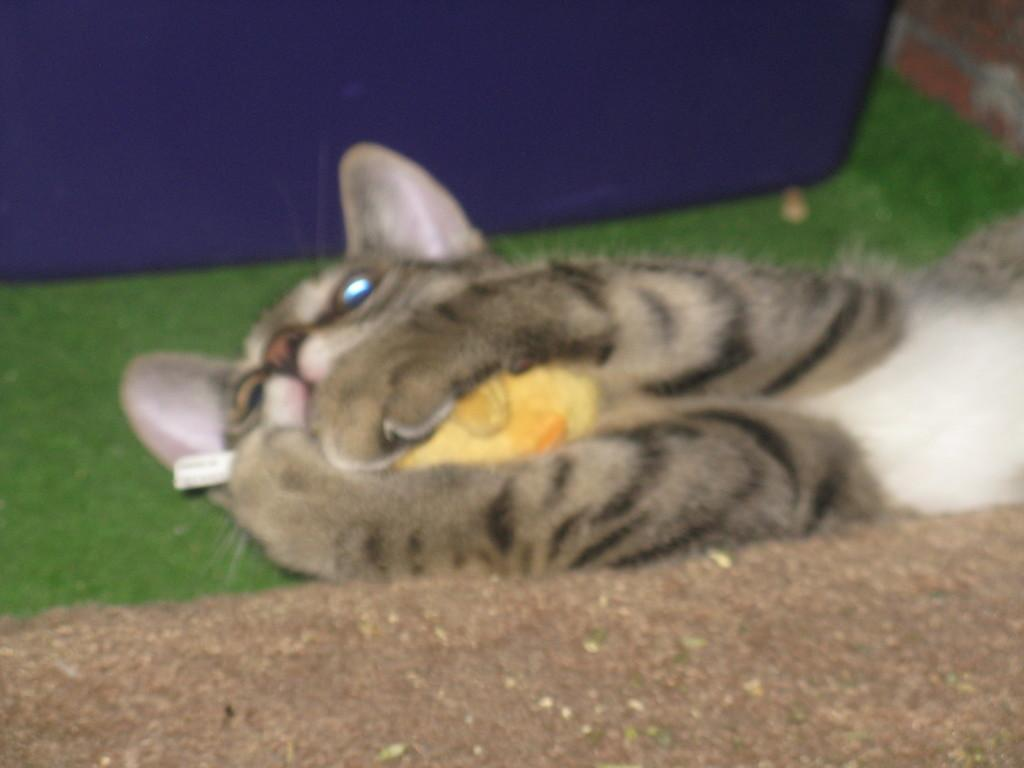What animal can be seen in the image? There is a cat in the image. What is the cat doing in the image? The cat is lying on the ground. What is the cat holding in the image? The cat is holding a yellow object. What color is the object in the background of the image? There is a blue object in the background of the image. What type of society is depicted in the image? There is no society depicted in the image; it features a cat lying on the ground and holding a yellow object. What type of cub can be seen playing with the cat in the image? There is no cub present in the image; it only features a cat holding a yellow object. 